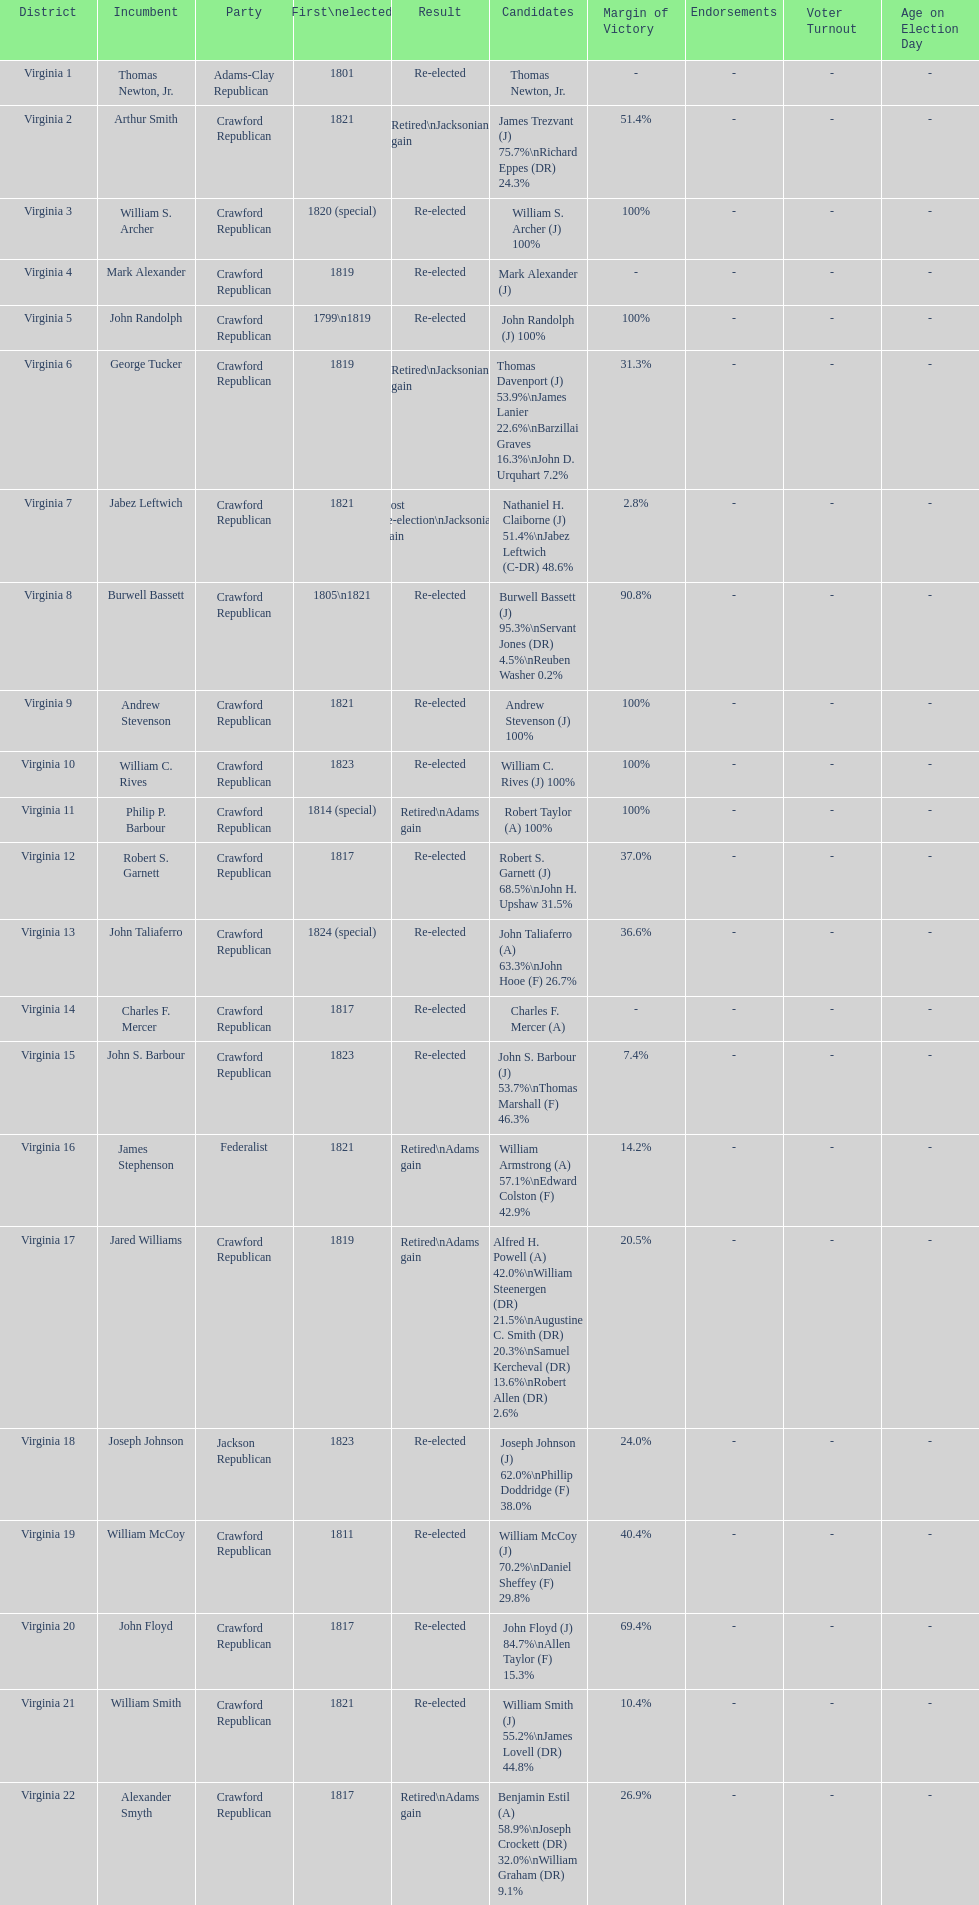What is the total number of districts in virginia? 22. 